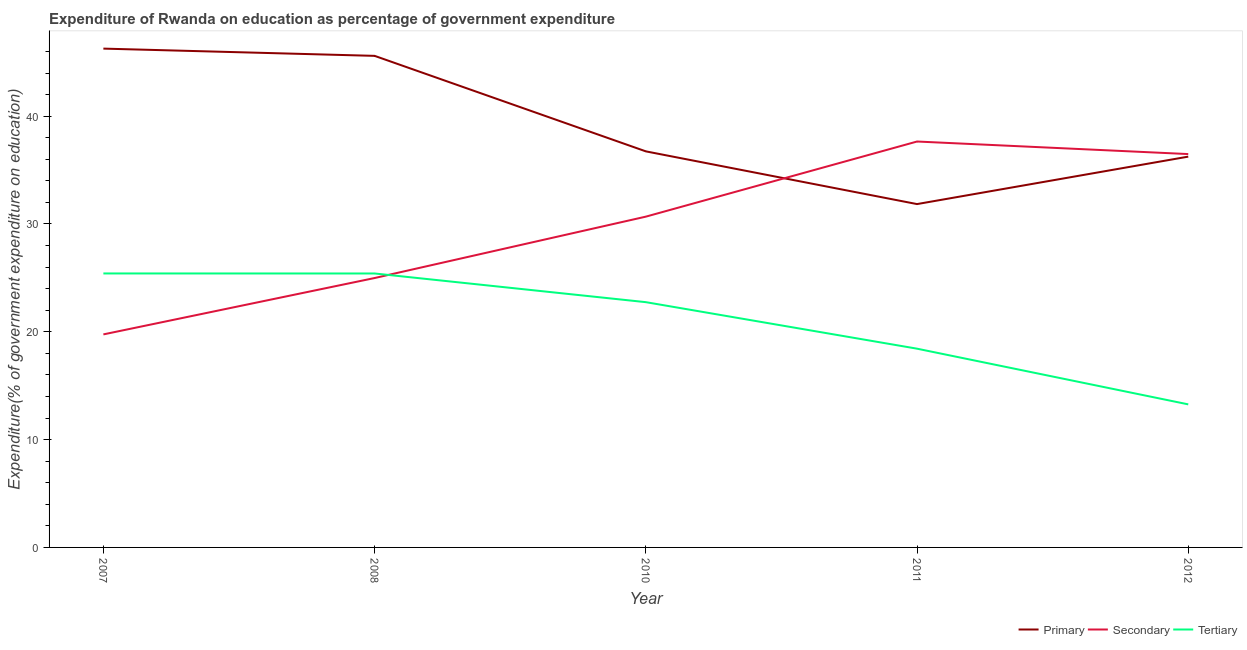How many different coloured lines are there?
Give a very brief answer. 3. Does the line corresponding to expenditure on secondary education intersect with the line corresponding to expenditure on tertiary education?
Your response must be concise. Yes. Is the number of lines equal to the number of legend labels?
Offer a terse response. Yes. What is the expenditure on tertiary education in 2010?
Give a very brief answer. 22.75. Across all years, what is the maximum expenditure on primary education?
Offer a terse response. 46.27. Across all years, what is the minimum expenditure on tertiary education?
Ensure brevity in your answer.  13.27. In which year was the expenditure on secondary education maximum?
Your answer should be very brief. 2011. What is the total expenditure on primary education in the graph?
Offer a very short reply. 196.69. What is the difference between the expenditure on tertiary education in 2010 and that in 2012?
Give a very brief answer. 9.48. What is the difference between the expenditure on primary education in 2007 and the expenditure on secondary education in 2008?
Make the answer very short. 21.28. What is the average expenditure on secondary education per year?
Provide a short and direct response. 29.91. In the year 2011, what is the difference between the expenditure on primary education and expenditure on tertiary education?
Offer a very short reply. 13.41. What is the ratio of the expenditure on tertiary education in 2008 to that in 2010?
Give a very brief answer. 1.12. Is the expenditure on primary education in 2008 less than that in 2012?
Provide a short and direct response. No. What is the difference between the highest and the second highest expenditure on tertiary education?
Give a very brief answer. 0. What is the difference between the highest and the lowest expenditure on primary education?
Make the answer very short. 14.42. In how many years, is the expenditure on secondary education greater than the average expenditure on secondary education taken over all years?
Provide a short and direct response. 3. Is it the case that in every year, the sum of the expenditure on primary education and expenditure on secondary education is greater than the expenditure on tertiary education?
Provide a short and direct response. Yes. Does the expenditure on secondary education monotonically increase over the years?
Keep it short and to the point. No. Is the expenditure on tertiary education strictly greater than the expenditure on primary education over the years?
Provide a short and direct response. No. Is the expenditure on primary education strictly less than the expenditure on secondary education over the years?
Your response must be concise. No. Are the values on the major ticks of Y-axis written in scientific E-notation?
Your answer should be compact. No. Where does the legend appear in the graph?
Give a very brief answer. Bottom right. How many legend labels are there?
Provide a short and direct response. 3. How are the legend labels stacked?
Your response must be concise. Horizontal. What is the title of the graph?
Make the answer very short. Expenditure of Rwanda on education as percentage of government expenditure. What is the label or title of the X-axis?
Offer a very short reply. Year. What is the label or title of the Y-axis?
Make the answer very short. Expenditure(% of government expenditure on education). What is the Expenditure(% of government expenditure on education) of Primary in 2007?
Your answer should be very brief. 46.27. What is the Expenditure(% of government expenditure on education) in Secondary in 2007?
Provide a succinct answer. 19.76. What is the Expenditure(% of government expenditure on education) in Tertiary in 2007?
Give a very brief answer. 25.41. What is the Expenditure(% of government expenditure on education) of Primary in 2008?
Provide a short and direct response. 45.6. What is the Expenditure(% of government expenditure on education) of Secondary in 2008?
Your answer should be compact. 24.99. What is the Expenditure(% of government expenditure on education) of Tertiary in 2008?
Ensure brevity in your answer.  25.41. What is the Expenditure(% of government expenditure on education) in Primary in 2010?
Your response must be concise. 36.74. What is the Expenditure(% of government expenditure on education) of Secondary in 2010?
Ensure brevity in your answer.  30.68. What is the Expenditure(% of government expenditure on education) in Tertiary in 2010?
Provide a succinct answer. 22.75. What is the Expenditure(% of government expenditure on education) in Primary in 2011?
Provide a succinct answer. 31.85. What is the Expenditure(% of government expenditure on education) of Secondary in 2011?
Make the answer very short. 37.65. What is the Expenditure(% of government expenditure on education) of Tertiary in 2011?
Provide a short and direct response. 18.43. What is the Expenditure(% of government expenditure on education) in Primary in 2012?
Provide a short and direct response. 36.25. What is the Expenditure(% of government expenditure on education) in Secondary in 2012?
Keep it short and to the point. 36.49. What is the Expenditure(% of government expenditure on education) in Tertiary in 2012?
Ensure brevity in your answer.  13.27. Across all years, what is the maximum Expenditure(% of government expenditure on education) of Primary?
Offer a very short reply. 46.27. Across all years, what is the maximum Expenditure(% of government expenditure on education) in Secondary?
Make the answer very short. 37.65. Across all years, what is the maximum Expenditure(% of government expenditure on education) of Tertiary?
Provide a succinct answer. 25.41. Across all years, what is the minimum Expenditure(% of government expenditure on education) of Primary?
Make the answer very short. 31.85. Across all years, what is the minimum Expenditure(% of government expenditure on education) in Secondary?
Offer a very short reply. 19.76. Across all years, what is the minimum Expenditure(% of government expenditure on education) in Tertiary?
Ensure brevity in your answer.  13.27. What is the total Expenditure(% of government expenditure on education) of Primary in the graph?
Your response must be concise. 196.69. What is the total Expenditure(% of government expenditure on education) in Secondary in the graph?
Your answer should be compact. 149.56. What is the total Expenditure(% of government expenditure on education) in Tertiary in the graph?
Provide a succinct answer. 105.28. What is the difference between the Expenditure(% of government expenditure on education) in Primary in 2007 and that in 2008?
Keep it short and to the point. 0.67. What is the difference between the Expenditure(% of government expenditure on education) of Secondary in 2007 and that in 2008?
Your answer should be very brief. -5.23. What is the difference between the Expenditure(% of government expenditure on education) of Tertiary in 2007 and that in 2008?
Make the answer very short. 0. What is the difference between the Expenditure(% of government expenditure on education) in Primary in 2007 and that in 2010?
Your response must be concise. 9.53. What is the difference between the Expenditure(% of government expenditure on education) of Secondary in 2007 and that in 2010?
Give a very brief answer. -10.92. What is the difference between the Expenditure(% of government expenditure on education) in Tertiary in 2007 and that in 2010?
Keep it short and to the point. 2.66. What is the difference between the Expenditure(% of government expenditure on education) in Primary in 2007 and that in 2011?
Make the answer very short. 14.42. What is the difference between the Expenditure(% of government expenditure on education) of Secondary in 2007 and that in 2011?
Keep it short and to the point. -17.89. What is the difference between the Expenditure(% of government expenditure on education) in Tertiary in 2007 and that in 2011?
Give a very brief answer. 6.98. What is the difference between the Expenditure(% of government expenditure on education) in Primary in 2007 and that in 2012?
Your answer should be very brief. 10.02. What is the difference between the Expenditure(% of government expenditure on education) in Secondary in 2007 and that in 2012?
Your response must be concise. -16.73. What is the difference between the Expenditure(% of government expenditure on education) in Tertiary in 2007 and that in 2012?
Your response must be concise. 12.14. What is the difference between the Expenditure(% of government expenditure on education) in Primary in 2008 and that in 2010?
Your response must be concise. 8.86. What is the difference between the Expenditure(% of government expenditure on education) of Secondary in 2008 and that in 2010?
Provide a short and direct response. -5.69. What is the difference between the Expenditure(% of government expenditure on education) in Tertiary in 2008 and that in 2010?
Make the answer very short. 2.66. What is the difference between the Expenditure(% of government expenditure on education) in Primary in 2008 and that in 2011?
Offer a terse response. 13.75. What is the difference between the Expenditure(% of government expenditure on education) in Secondary in 2008 and that in 2011?
Provide a short and direct response. -12.66. What is the difference between the Expenditure(% of government expenditure on education) of Tertiary in 2008 and that in 2011?
Your answer should be very brief. 6.97. What is the difference between the Expenditure(% of government expenditure on education) of Primary in 2008 and that in 2012?
Your answer should be compact. 9.35. What is the difference between the Expenditure(% of government expenditure on education) of Secondary in 2008 and that in 2012?
Provide a short and direct response. -11.5. What is the difference between the Expenditure(% of government expenditure on education) in Tertiary in 2008 and that in 2012?
Offer a very short reply. 12.14. What is the difference between the Expenditure(% of government expenditure on education) in Primary in 2010 and that in 2011?
Make the answer very short. 4.89. What is the difference between the Expenditure(% of government expenditure on education) in Secondary in 2010 and that in 2011?
Make the answer very short. -6.97. What is the difference between the Expenditure(% of government expenditure on education) in Tertiary in 2010 and that in 2011?
Ensure brevity in your answer.  4.31. What is the difference between the Expenditure(% of government expenditure on education) of Primary in 2010 and that in 2012?
Your answer should be very brief. 0.49. What is the difference between the Expenditure(% of government expenditure on education) in Secondary in 2010 and that in 2012?
Give a very brief answer. -5.8. What is the difference between the Expenditure(% of government expenditure on education) of Tertiary in 2010 and that in 2012?
Keep it short and to the point. 9.48. What is the difference between the Expenditure(% of government expenditure on education) in Primary in 2011 and that in 2012?
Make the answer very short. -4.4. What is the difference between the Expenditure(% of government expenditure on education) in Secondary in 2011 and that in 2012?
Your answer should be compact. 1.16. What is the difference between the Expenditure(% of government expenditure on education) of Tertiary in 2011 and that in 2012?
Give a very brief answer. 5.17. What is the difference between the Expenditure(% of government expenditure on education) in Primary in 2007 and the Expenditure(% of government expenditure on education) in Secondary in 2008?
Provide a succinct answer. 21.28. What is the difference between the Expenditure(% of government expenditure on education) in Primary in 2007 and the Expenditure(% of government expenditure on education) in Tertiary in 2008?
Make the answer very short. 20.86. What is the difference between the Expenditure(% of government expenditure on education) of Secondary in 2007 and the Expenditure(% of government expenditure on education) of Tertiary in 2008?
Make the answer very short. -5.65. What is the difference between the Expenditure(% of government expenditure on education) in Primary in 2007 and the Expenditure(% of government expenditure on education) in Secondary in 2010?
Provide a succinct answer. 15.59. What is the difference between the Expenditure(% of government expenditure on education) in Primary in 2007 and the Expenditure(% of government expenditure on education) in Tertiary in 2010?
Give a very brief answer. 23.52. What is the difference between the Expenditure(% of government expenditure on education) in Secondary in 2007 and the Expenditure(% of government expenditure on education) in Tertiary in 2010?
Your answer should be compact. -2.99. What is the difference between the Expenditure(% of government expenditure on education) in Primary in 2007 and the Expenditure(% of government expenditure on education) in Secondary in 2011?
Offer a very short reply. 8.62. What is the difference between the Expenditure(% of government expenditure on education) in Primary in 2007 and the Expenditure(% of government expenditure on education) in Tertiary in 2011?
Give a very brief answer. 27.83. What is the difference between the Expenditure(% of government expenditure on education) in Secondary in 2007 and the Expenditure(% of government expenditure on education) in Tertiary in 2011?
Provide a short and direct response. 1.32. What is the difference between the Expenditure(% of government expenditure on education) of Primary in 2007 and the Expenditure(% of government expenditure on education) of Secondary in 2012?
Your answer should be compact. 9.78. What is the difference between the Expenditure(% of government expenditure on education) in Primary in 2007 and the Expenditure(% of government expenditure on education) in Tertiary in 2012?
Make the answer very short. 33. What is the difference between the Expenditure(% of government expenditure on education) of Secondary in 2007 and the Expenditure(% of government expenditure on education) of Tertiary in 2012?
Provide a succinct answer. 6.49. What is the difference between the Expenditure(% of government expenditure on education) in Primary in 2008 and the Expenditure(% of government expenditure on education) in Secondary in 2010?
Give a very brief answer. 14.91. What is the difference between the Expenditure(% of government expenditure on education) of Primary in 2008 and the Expenditure(% of government expenditure on education) of Tertiary in 2010?
Your answer should be very brief. 22.85. What is the difference between the Expenditure(% of government expenditure on education) of Secondary in 2008 and the Expenditure(% of government expenditure on education) of Tertiary in 2010?
Your answer should be compact. 2.24. What is the difference between the Expenditure(% of government expenditure on education) in Primary in 2008 and the Expenditure(% of government expenditure on education) in Secondary in 2011?
Ensure brevity in your answer.  7.95. What is the difference between the Expenditure(% of government expenditure on education) in Primary in 2008 and the Expenditure(% of government expenditure on education) in Tertiary in 2011?
Keep it short and to the point. 27.16. What is the difference between the Expenditure(% of government expenditure on education) of Secondary in 2008 and the Expenditure(% of government expenditure on education) of Tertiary in 2011?
Provide a short and direct response. 6.55. What is the difference between the Expenditure(% of government expenditure on education) of Primary in 2008 and the Expenditure(% of government expenditure on education) of Secondary in 2012?
Provide a short and direct response. 9.11. What is the difference between the Expenditure(% of government expenditure on education) in Primary in 2008 and the Expenditure(% of government expenditure on education) in Tertiary in 2012?
Provide a succinct answer. 32.33. What is the difference between the Expenditure(% of government expenditure on education) of Secondary in 2008 and the Expenditure(% of government expenditure on education) of Tertiary in 2012?
Make the answer very short. 11.72. What is the difference between the Expenditure(% of government expenditure on education) of Primary in 2010 and the Expenditure(% of government expenditure on education) of Secondary in 2011?
Offer a very short reply. -0.91. What is the difference between the Expenditure(% of government expenditure on education) in Primary in 2010 and the Expenditure(% of government expenditure on education) in Tertiary in 2011?
Offer a very short reply. 18.3. What is the difference between the Expenditure(% of government expenditure on education) in Secondary in 2010 and the Expenditure(% of government expenditure on education) in Tertiary in 2011?
Your response must be concise. 12.25. What is the difference between the Expenditure(% of government expenditure on education) of Primary in 2010 and the Expenditure(% of government expenditure on education) of Secondary in 2012?
Your response must be concise. 0.25. What is the difference between the Expenditure(% of government expenditure on education) in Primary in 2010 and the Expenditure(% of government expenditure on education) in Tertiary in 2012?
Ensure brevity in your answer.  23.47. What is the difference between the Expenditure(% of government expenditure on education) in Secondary in 2010 and the Expenditure(% of government expenditure on education) in Tertiary in 2012?
Make the answer very short. 17.41. What is the difference between the Expenditure(% of government expenditure on education) of Primary in 2011 and the Expenditure(% of government expenditure on education) of Secondary in 2012?
Offer a very short reply. -4.64. What is the difference between the Expenditure(% of government expenditure on education) of Primary in 2011 and the Expenditure(% of government expenditure on education) of Tertiary in 2012?
Offer a terse response. 18.58. What is the difference between the Expenditure(% of government expenditure on education) of Secondary in 2011 and the Expenditure(% of government expenditure on education) of Tertiary in 2012?
Provide a succinct answer. 24.38. What is the average Expenditure(% of government expenditure on education) of Primary per year?
Provide a short and direct response. 39.34. What is the average Expenditure(% of government expenditure on education) of Secondary per year?
Your answer should be compact. 29.91. What is the average Expenditure(% of government expenditure on education) in Tertiary per year?
Give a very brief answer. 21.06. In the year 2007, what is the difference between the Expenditure(% of government expenditure on education) of Primary and Expenditure(% of government expenditure on education) of Secondary?
Provide a succinct answer. 26.51. In the year 2007, what is the difference between the Expenditure(% of government expenditure on education) in Primary and Expenditure(% of government expenditure on education) in Tertiary?
Provide a succinct answer. 20.86. In the year 2007, what is the difference between the Expenditure(% of government expenditure on education) in Secondary and Expenditure(% of government expenditure on education) in Tertiary?
Your response must be concise. -5.65. In the year 2008, what is the difference between the Expenditure(% of government expenditure on education) of Primary and Expenditure(% of government expenditure on education) of Secondary?
Your answer should be compact. 20.61. In the year 2008, what is the difference between the Expenditure(% of government expenditure on education) of Primary and Expenditure(% of government expenditure on education) of Tertiary?
Give a very brief answer. 20.19. In the year 2008, what is the difference between the Expenditure(% of government expenditure on education) of Secondary and Expenditure(% of government expenditure on education) of Tertiary?
Ensure brevity in your answer.  -0.42. In the year 2010, what is the difference between the Expenditure(% of government expenditure on education) in Primary and Expenditure(% of government expenditure on education) in Secondary?
Provide a succinct answer. 6.06. In the year 2010, what is the difference between the Expenditure(% of government expenditure on education) in Primary and Expenditure(% of government expenditure on education) in Tertiary?
Offer a very short reply. 13.99. In the year 2010, what is the difference between the Expenditure(% of government expenditure on education) of Secondary and Expenditure(% of government expenditure on education) of Tertiary?
Make the answer very short. 7.93. In the year 2011, what is the difference between the Expenditure(% of government expenditure on education) of Primary and Expenditure(% of government expenditure on education) of Secondary?
Give a very brief answer. -5.8. In the year 2011, what is the difference between the Expenditure(% of government expenditure on education) in Primary and Expenditure(% of government expenditure on education) in Tertiary?
Give a very brief answer. 13.41. In the year 2011, what is the difference between the Expenditure(% of government expenditure on education) of Secondary and Expenditure(% of government expenditure on education) of Tertiary?
Give a very brief answer. 19.21. In the year 2012, what is the difference between the Expenditure(% of government expenditure on education) of Primary and Expenditure(% of government expenditure on education) of Secondary?
Your response must be concise. -0.24. In the year 2012, what is the difference between the Expenditure(% of government expenditure on education) in Primary and Expenditure(% of government expenditure on education) in Tertiary?
Your response must be concise. 22.98. In the year 2012, what is the difference between the Expenditure(% of government expenditure on education) of Secondary and Expenditure(% of government expenditure on education) of Tertiary?
Make the answer very short. 23.22. What is the ratio of the Expenditure(% of government expenditure on education) in Primary in 2007 to that in 2008?
Provide a succinct answer. 1.01. What is the ratio of the Expenditure(% of government expenditure on education) in Secondary in 2007 to that in 2008?
Offer a terse response. 0.79. What is the ratio of the Expenditure(% of government expenditure on education) in Primary in 2007 to that in 2010?
Give a very brief answer. 1.26. What is the ratio of the Expenditure(% of government expenditure on education) in Secondary in 2007 to that in 2010?
Keep it short and to the point. 0.64. What is the ratio of the Expenditure(% of government expenditure on education) in Tertiary in 2007 to that in 2010?
Make the answer very short. 1.12. What is the ratio of the Expenditure(% of government expenditure on education) of Primary in 2007 to that in 2011?
Offer a very short reply. 1.45. What is the ratio of the Expenditure(% of government expenditure on education) of Secondary in 2007 to that in 2011?
Provide a succinct answer. 0.52. What is the ratio of the Expenditure(% of government expenditure on education) of Tertiary in 2007 to that in 2011?
Your response must be concise. 1.38. What is the ratio of the Expenditure(% of government expenditure on education) in Primary in 2007 to that in 2012?
Your answer should be compact. 1.28. What is the ratio of the Expenditure(% of government expenditure on education) of Secondary in 2007 to that in 2012?
Offer a terse response. 0.54. What is the ratio of the Expenditure(% of government expenditure on education) of Tertiary in 2007 to that in 2012?
Your answer should be very brief. 1.92. What is the ratio of the Expenditure(% of government expenditure on education) of Primary in 2008 to that in 2010?
Ensure brevity in your answer.  1.24. What is the ratio of the Expenditure(% of government expenditure on education) of Secondary in 2008 to that in 2010?
Provide a succinct answer. 0.81. What is the ratio of the Expenditure(% of government expenditure on education) in Tertiary in 2008 to that in 2010?
Offer a very short reply. 1.12. What is the ratio of the Expenditure(% of government expenditure on education) in Primary in 2008 to that in 2011?
Keep it short and to the point. 1.43. What is the ratio of the Expenditure(% of government expenditure on education) in Secondary in 2008 to that in 2011?
Provide a short and direct response. 0.66. What is the ratio of the Expenditure(% of government expenditure on education) in Tertiary in 2008 to that in 2011?
Provide a succinct answer. 1.38. What is the ratio of the Expenditure(% of government expenditure on education) in Primary in 2008 to that in 2012?
Give a very brief answer. 1.26. What is the ratio of the Expenditure(% of government expenditure on education) in Secondary in 2008 to that in 2012?
Offer a terse response. 0.68. What is the ratio of the Expenditure(% of government expenditure on education) of Tertiary in 2008 to that in 2012?
Your response must be concise. 1.92. What is the ratio of the Expenditure(% of government expenditure on education) in Primary in 2010 to that in 2011?
Ensure brevity in your answer.  1.15. What is the ratio of the Expenditure(% of government expenditure on education) of Secondary in 2010 to that in 2011?
Your response must be concise. 0.81. What is the ratio of the Expenditure(% of government expenditure on education) of Tertiary in 2010 to that in 2011?
Your answer should be compact. 1.23. What is the ratio of the Expenditure(% of government expenditure on education) in Primary in 2010 to that in 2012?
Offer a very short reply. 1.01. What is the ratio of the Expenditure(% of government expenditure on education) in Secondary in 2010 to that in 2012?
Your response must be concise. 0.84. What is the ratio of the Expenditure(% of government expenditure on education) in Tertiary in 2010 to that in 2012?
Offer a terse response. 1.71. What is the ratio of the Expenditure(% of government expenditure on education) of Primary in 2011 to that in 2012?
Your answer should be compact. 0.88. What is the ratio of the Expenditure(% of government expenditure on education) of Secondary in 2011 to that in 2012?
Make the answer very short. 1.03. What is the ratio of the Expenditure(% of government expenditure on education) in Tertiary in 2011 to that in 2012?
Provide a succinct answer. 1.39. What is the difference between the highest and the second highest Expenditure(% of government expenditure on education) of Primary?
Give a very brief answer. 0.67. What is the difference between the highest and the second highest Expenditure(% of government expenditure on education) of Secondary?
Make the answer very short. 1.16. What is the difference between the highest and the second highest Expenditure(% of government expenditure on education) in Tertiary?
Keep it short and to the point. 0. What is the difference between the highest and the lowest Expenditure(% of government expenditure on education) in Primary?
Your answer should be very brief. 14.42. What is the difference between the highest and the lowest Expenditure(% of government expenditure on education) in Secondary?
Offer a very short reply. 17.89. What is the difference between the highest and the lowest Expenditure(% of government expenditure on education) in Tertiary?
Offer a very short reply. 12.14. 